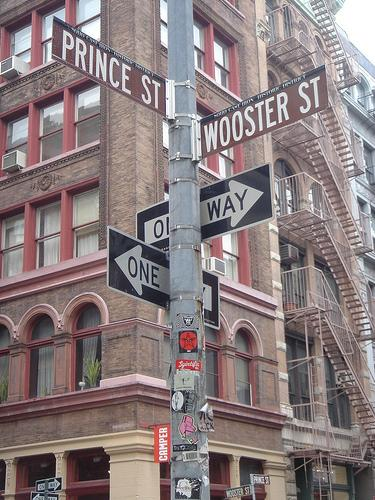Is there anything attached to the building or visible on its wall? There are stairs, a ladder, and an air conditioner attached to the building. Estimate the total number of signs and stickers present in the image. There are at least 22 signs and several stickers on the pole. Describe the content of any text written on the signs. Some signs have text like "street", "camper", "one way", "Wooster Street", and "Prince St". Based on the descriptions provided, how would you rate the image in terms of quality and detail? The image is of high quality and detail, as it contains various objects and their respective characteristics. What kind of objects can be found near the pole? Signs, stickers, a window, a plant, and an air conditioner can be found near the pole. What type of object is interacting with the window in the image? A green plant and an air conditioner are interacting with the window. Determine a possible time of day for the image and provide reasoning. The image is likely taken during day time, as the sky is white, and there are no mentions of shadows or darkness. Identify the main colors of the signs and the type of signs in the image. There are brown and white signs, black and white signs, and a red and white camper sign, which include street signs, arrow signs, and one way signs. Provide a brief description of the scene in the image. The image contains a city scene with various street signs in different colors, a window, a plant, an air conditioner, stairs, and a pole with many stickers on it. How would you describe the overall sentiment of the image? The image has a neutral sentiment, as it is a regular street scene with no specific emotions associated with it. Is there a purple plant on the window sill? The plant on the window sill is green, so suggesting it is purple is misleading. Is the air conditioner attached to the roof? The air conditioner is fixed to the window, so suggesting it is attached to the roof is misleading. Is the arrow sign blue and yellow? The arrow sign is black and white according to the given information, so suggesting it is blue and yellow is misleading. Are there three one-way signs on the pole? There are only two one-way signs on the pole according to the given information, so suggesting there are three is misleading. Are there no stickers on the grey-colored street pole? There are multiple stickers on the pole, so suggesting there are none is misleading. 